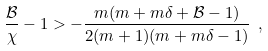<formula> <loc_0><loc_0><loc_500><loc_500>\frac { \mathcal { B } } { \chi } - 1 > - \frac { m ( m + m \delta + { \mathcal { B } } - 1 ) } { 2 ( m + 1 ) ( m + m \delta - 1 ) } \ ,</formula> 